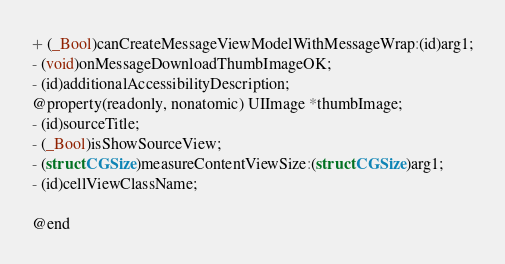<code> <loc_0><loc_0><loc_500><loc_500><_C_>
+ (_Bool)canCreateMessageViewModelWithMessageWrap:(id)arg1;
- (void)onMessageDownloadThumbImageOK;
- (id)additionalAccessibilityDescription;
@property(readonly, nonatomic) UIImage *thumbImage;
- (id)sourceTitle;
- (_Bool)isShowSourceView;
- (struct CGSize)measureContentViewSize:(struct CGSize)arg1;
- (id)cellViewClassName;

@end

</code> 